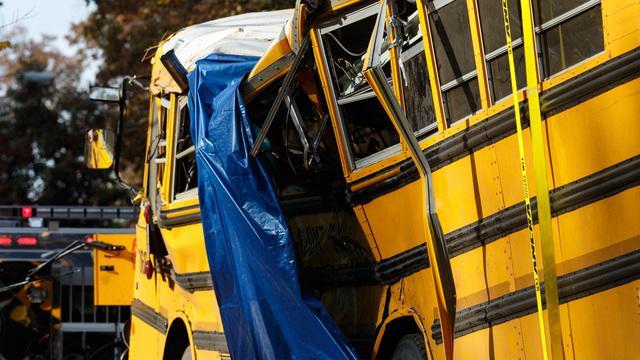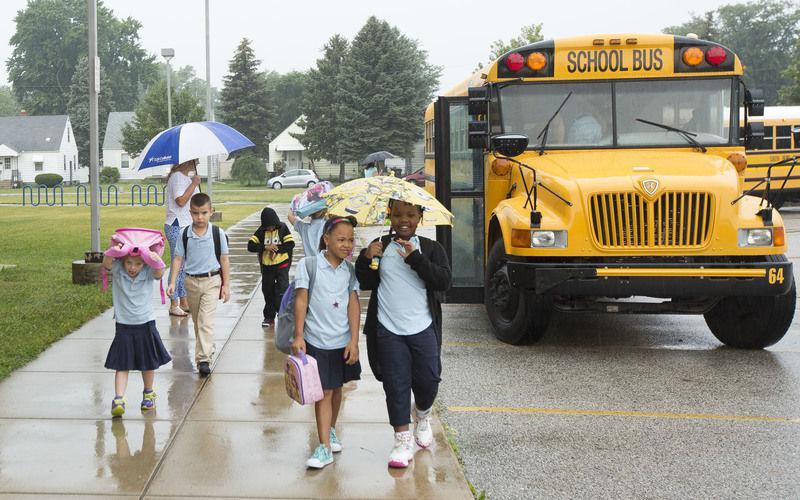The first image is the image on the left, the second image is the image on the right. Assess this claim about the two images: "A severely damaged school bus has a blue tarp hanging down the side.". Correct or not? Answer yes or no. Yes. The first image is the image on the left, the second image is the image on the right. Examine the images to the left and right. Is the description "One image shows a blue tarp covering part of the crumpled side of a yellow bus." accurate? Answer yes or no. Yes. 